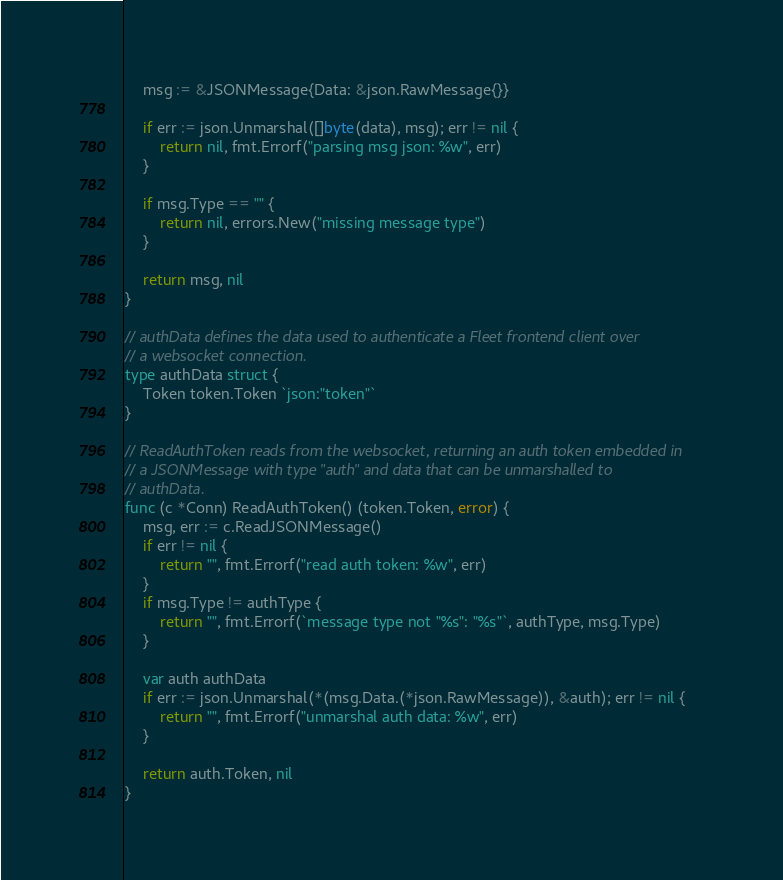Convert code to text. <code><loc_0><loc_0><loc_500><loc_500><_Go_>	msg := &JSONMessage{Data: &json.RawMessage{}}

	if err := json.Unmarshal([]byte(data), msg); err != nil {
		return nil, fmt.Errorf("parsing msg json: %w", err)
	}

	if msg.Type == "" {
		return nil, errors.New("missing message type")
	}

	return msg, nil
}

// authData defines the data used to authenticate a Fleet frontend client over
// a websocket connection.
type authData struct {
	Token token.Token `json:"token"`
}

// ReadAuthToken reads from the websocket, returning an auth token embedded in
// a JSONMessage with type "auth" and data that can be unmarshalled to
// authData.
func (c *Conn) ReadAuthToken() (token.Token, error) {
	msg, err := c.ReadJSONMessage()
	if err != nil {
		return "", fmt.Errorf("read auth token: %w", err)
	}
	if msg.Type != authType {
		return "", fmt.Errorf(`message type not "%s": "%s"`, authType, msg.Type)
	}

	var auth authData
	if err := json.Unmarshal(*(msg.Data.(*json.RawMessage)), &auth); err != nil {
		return "", fmt.Errorf("unmarshal auth data: %w", err)
	}

	return auth.Token, nil
}
</code> 